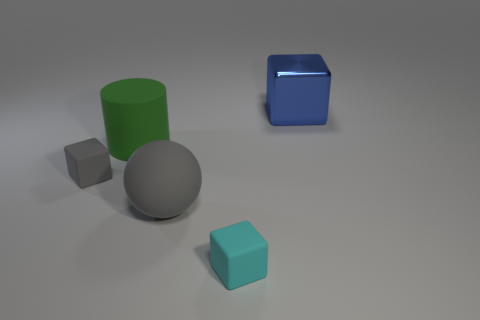Add 1 blue metal blocks. How many objects exist? 6 Subtract all spheres. How many objects are left? 4 Subtract all tiny gray blocks. Subtract all blue metal things. How many objects are left? 3 Add 2 gray matte things. How many gray matte things are left? 4 Add 4 large spheres. How many large spheres exist? 5 Subtract 0 green cubes. How many objects are left? 5 